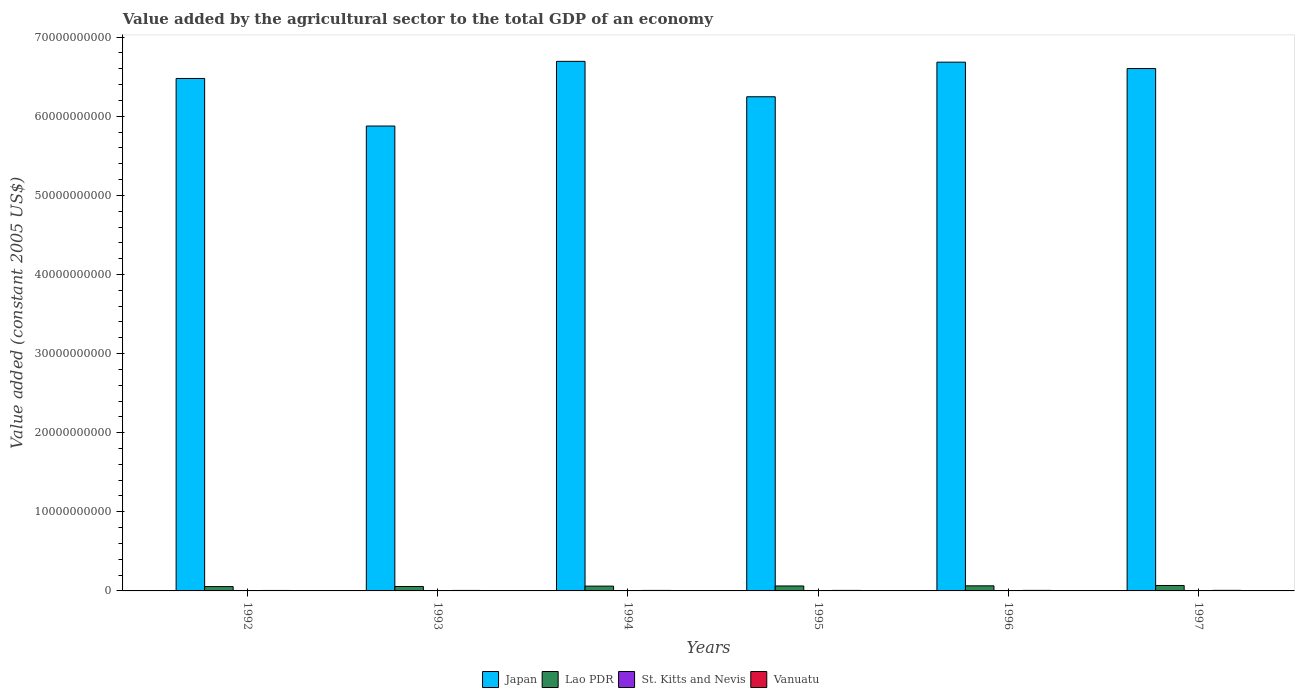Are the number of bars on each tick of the X-axis equal?
Ensure brevity in your answer.  Yes. How many bars are there on the 3rd tick from the right?
Your answer should be very brief. 4. In how many cases, is the number of bars for a given year not equal to the number of legend labels?
Keep it short and to the point. 0. What is the value added by the agricultural sector in Japan in 1995?
Make the answer very short. 6.25e+1. Across all years, what is the maximum value added by the agricultural sector in Vanuatu?
Your response must be concise. 7.22e+07. Across all years, what is the minimum value added by the agricultural sector in Lao PDR?
Keep it short and to the point. 5.46e+08. What is the total value added by the agricultural sector in St. Kitts and Nevis in the graph?
Your answer should be very brief. 4.08e+07. What is the difference between the value added by the agricultural sector in Vanuatu in 1994 and that in 1997?
Offer a very short reply. -8.80e+06. What is the difference between the value added by the agricultural sector in St. Kitts and Nevis in 1997 and the value added by the agricultural sector in Japan in 1995?
Give a very brief answer. -6.25e+1. What is the average value added by the agricultural sector in St. Kitts and Nevis per year?
Your response must be concise. 6.80e+06. In the year 1994, what is the difference between the value added by the agricultural sector in St. Kitts and Nevis and value added by the agricultural sector in Japan?
Ensure brevity in your answer.  -6.69e+1. What is the ratio of the value added by the agricultural sector in Lao PDR in 1993 to that in 1994?
Keep it short and to the point. 0.92. Is the value added by the agricultural sector in Japan in 1994 less than that in 1995?
Your answer should be very brief. No. Is the difference between the value added by the agricultural sector in St. Kitts and Nevis in 1994 and 1996 greater than the difference between the value added by the agricultural sector in Japan in 1994 and 1996?
Make the answer very short. No. What is the difference between the highest and the second highest value added by the agricultural sector in Japan?
Offer a very short reply. 1.02e+08. What is the difference between the highest and the lowest value added by the agricultural sector in Vanuatu?
Your response must be concise. 1.40e+07. In how many years, is the value added by the agricultural sector in Vanuatu greater than the average value added by the agricultural sector in Vanuatu taken over all years?
Keep it short and to the point. 3. Is the sum of the value added by the agricultural sector in Japan in 1995 and 1996 greater than the maximum value added by the agricultural sector in St. Kitts and Nevis across all years?
Provide a succinct answer. Yes. Is it the case that in every year, the sum of the value added by the agricultural sector in Vanuatu and value added by the agricultural sector in Japan is greater than the sum of value added by the agricultural sector in Lao PDR and value added by the agricultural sector in St. Kitts and Nevis?
Provide a succinct answer. No. What does the 1st bar from the right in 1992 represents?
Offer a very short reply. Vanuatu. What is the difference between two consecutive major ticks on the Y-axis?
Provide a short and direct response. 1.00e+1. Does the graph contain grids?
Your answer should be compact. No. Where does the legend appear in the graph?
Your answer should be very brief. Bottom center. What is the title of the graph?
Provide a succinct answer. Value added by the agricultural sector to the total GDP of an economy. What is the label or title of the Y-axis?
Ensure brevity in your answer.  Value added (constant 2005 US$). What is the Value added (constant 2005 US$) in Japan in 1992?
Keep it short and to the point. 6.48e+1. What is the Value added (constant 2005 US$) in Lao PDR in 1992?
Your answer should be compact. 5.46e+08. What is the Value added (constant 2005 US$) in St. Kitts and Nevis in 1992?
Provide a succinct answer. 6.82e+06. What is the Value added (constant 2005 US$) of Vanuatu in 1992?
Your answer should be very brief. 5.82e+07. What is the Value added (constant 2005 US$) of Japan in 1993?
Provide a short and direct response. 5.88e+1. What is the Value added (constant 2005 US$) of Lao PDR in 1993?
Give a very brief answer. 5.60e+08. What is the Value added (constant 2005 US$) in St. Kitts and Nevis in 1993?
Keep it short and to the point. 7.05e+06. What is the Value added (constant 2005 US$) of Vanuatu in 1993?
Your answer should be very brief. 6.26e+07. What is the Value added (constant 2005 US$) in Japan in 1994?
Your answer should be compact. 6.69e+1. What is the Value added (constant 2005 US$) in Lao PDR in 1994?
Keep it short and to the point. 6.07e+08. What is the Value added (constant 2005 US$) of St. Kitts and Nevis in 1994?
Your response must be concise. 7.30e+06. What is the Value added (constant 2005 US$) of Vanuatu in 1994?
Keep it short and to the point. 6.34e+07. What is the Value added (constant 2005 US$) in Japan in 1995?
Your answer should be compact. 6.25e+1. What is the Value added (constant 2005 US$) in Lao PDR in 1995?
Offer a terse response. 6.26e+08. What is the Value added (constant 2005 US$) of St. Kitts and Nevis in 1995?
Provide a succinct answer. 6.03e+06. What is the Value added (constant 2005 US$) of Vanuatu in 1995?
Give a very brief answer. 6.58e+07. What is the Value added (constant 2005 US$) of Japan in 1996?
Make the answer very short. 6.68e+1. What is the Value added (constant 2005 US$) of Lao PDR in 1996?
Ensure brevity in your answer.  6.43e+08. What is the Value added (constant 2005 US$) of St. Kitts and Nevis in 1996?
Offer a terse response. 6.71e+06. What is the Value added (constant 2005 US$) of Vanuatu in 1996?
Your answer should be very brief. 6.90e+07. What is the Value added (constant 2005 US$) in Japan in 1997?
Ensure brevity in your answer.  6.60e+1. What is the Value added (constant 2005 US$) in Lao PDR in 1997?
Your answer should be compact. 6.88e+08. What is the Value added (constant 2005 US$) in St. Kitts and Nevis in 1997?
Provide a short and direct response. 6.89e+06. What is the Value added (constant 2005 US$) in Vanuatu in 1997?
Your answer should be very brief. 7.22e+07. Across all years, what is the maximum Value added (constant 2005 US$) in Japan?
Offer a very short reply. 6.69e+1. Across all years, what is the maximum Value added (constant 2005 US$) in Lao PDR?
Offer a terse response. 6.88e+08. Across all years, what is the maximum Value added (constant 2005 US$) of St. Kitts and Nevis?
Ensure brevity in your answer.  7.30e+06. Across all years, what is the maximum Value added (constant 2005 US$) of Vanuatu?
Give a very brief answer. 7.22e+07. Across all years, what is the minimum Value added (constant 2005 US$) in Japan?
Ensure brevity in your answer.  5.88e+1. Across all years, what is the minimum Value added (constant 2005 US$) in Lao PDR?
Make the answer very short. 5.46e+08. Across all years, what is the minimum Value added (constant 2005 US$) of St. Kitts and Nevis?
Provide a succinct answer. 6.03e+06. Across all years, what is the minimum Value added (constant 2005 US$) of Vanuatu?
Keep it short and to the point. 5.82e+07. What is the total Value added (constant 2005 US$) in Japan in the graph?
Provide a short and direct response. 3.86e+11. What is the total Value added (constant 2005 US$) of Lao PDR in the graph?
Provide a short and direct response. 3.67e+09. What is the total Value added (constant 2005 US$) in St. Kitts and Nevis in the graph?
Give a very brief answer. 4.08e+07. What is the total Value added (constant 2005 US$) in Vanuatu in the graph?
Your answer should be very brief. 3.91e+08. What is the difference between the Value added (constant 2005 US$) in Japan in 1992 and that in 1993?
Provide a succinct answer. 6.01e+09. What is the difference between the Value added (constant 2005 US$) in Lao PDR in 1992 and that in 1993?
Your answer should be compact. -1.48e+07. What is the difference between the Value added (constant 2005 US$) of St. Kitts and Nevis in 1992 and that in 1993?
Offer a very short reply. -2.24e+05. What is the difference between the Value added (constant 2005 US$) in Vanuatu in 1992 and that in 1993?
Keep it short and to the point. -4.45e+06. What is the difference between the Value added (constant 2005 US$) in Japan in 1992 and that in 1994?
Offer a terse response. -2.16e+09. What is the difference between the Value added (constant 2005 US$) of Lao PDR in 1992 and that in 1994?
Your answer should be compact. -6.13e+07. What is the difference between the Value added (constant 2005 US$) in St. Kitts and Nevis in 1992 and that in 1994?
Your answer should be very brief. -4.82e+05. What is the difference between the Value added (constant 2005 US$) in Vanuatu in 1992 and that in 1994?
Give a very brief answer. -5.24e+06. What is the difference between the Value added (constant 2005 US$) of Japan in 1992 and that in 1995?
Provide a succinct answer. 2.31e+09. What is the difference between the Value added (constant 2005 US$) in Lao PDR in 1992 and that in 1995?
Your answer should be very brief. -8.03e+07. What is the difference between the Value added (constant 2005 US$) of St. Kitts and Nevis in 1992 and that in 1995?
Make the answer very short. 7.95e+05. What is the difference between the Value added (constant 2005 US$) of Vanuatu in 1992 and that in 1995?
Your response must be concise. -7.66e+06. What is the difference between the Value added (constant 2005 US$) of Japan in 1992 and that in 1996?
Your response must be concise. -2.06e+09. What is the difference between the Value added (constant 2005 US$) in Lao PDR in 1992 and that in 1996?
Your answer should be very brief. -9.69e+07. What is the difference between the Value added (constant 2005 US$) in St. Kitts and Nevis in 1992 and that in 1996?
Offer a terse response. 1.18e+05. What is the difference between the Value added (constant 2005 US$) of Vanuatu in 1992 and that in 1996?
Give a very brief answer. -1.08e+07. What is the difference between the Value added (constant 2005 US$) in Japan in 1992 and that in 1997?
Offer a terse response. -1.25e+09. What is the difference between the Value added (constant 2005 US$) of Lao PDR in 1992 and that in 1997?
Provide a succinct answer. -1.42e+08. What is the difference between the Value added (constant 2005 US$) in St. Kitts and Nevis in 1992 and that in 1997?
Provide a short and direct response. -6.55e+04. What is the difference between the Value added (constant 2005 US$) of Vanuatu in 1992 and that in 1997?
Your answer should be compact. -1.40e+07. What is the difference between the Value added (constant 2005 US$) of Japan in 1993 and that in 1994?
Provide a succinct answer. -8.18e+09. What is the difference between the Value added (constant 2005 US$) of Lao PDR in 1993 and that in 1994?
Provide a succinct answer. -4.65e+07. What is the difference between the Value added (constant 2005 US$) of St. Kitts and Nevis in 1993 and that in 1994?
Keep it short and to the point. -2.58e+05. What is the difference between the Value added (constant 2005 US$) of Vanuatu in 1993 and that in 1994?
Offer a very short reply. -7.90e+05. What is the difference between the Value added (constant 2005 US$) of Japan in 1993 and that in 1995?
Offer a terse response. -3.70e+09. What is the difference between the Value added (constant 2005 US$) of Lao PDR in 1993 and that in 1995?
Give a very brief answer. -6.56e+07. What is the difference between the Value added (constant 2005 US$) in St. Kitts and Nevis in 1993 and that in 1995?
Make the answer very short. 1.02e+06. What is the difference between the Value added (constant 2005 US$) in Vanuatu in 1993 and that in 1995?
Give a very brief answer. -3.21e+06. What is the difference between the Value added (constant 2005 US$) in Japan in 1993 and that in 1996?
Your answer should be very brief. -8.07e+09. What is the difference between the Value added (constant 2005 US$) of Lao PDR in 1993 and that in 1996?
Give a very brief answer. -8.21e+07. What is the difference between the Value added (constant 2005 US$) of St. Kitts and Nevis in 1993 and that in 1996?
Your answer should be very brief. 3.42e+05. What is the difference between the Value added (constant 2005 US$) in Vanuatu in 1993 and that in 1996?
Provide a succinct answer. -6.39e+06. What is the difference between the Value added (constant 2005 US$) in Japan in 1993 and that in 1997?
Provide a short and direct response. -7.26e+09. What is the difference between the Value added (constant 2005 US$) of Lao PDR in 1993 and that in 1997?
Your answer should be very brief. -1.28e+08. What is the difference between the Value added (constant 2005 US$) in St. Kitts and Nevis in 1993 and that in 1997?
Your response must be concise. 1.59e+05. What is the difference between the Value added (constant 2005 US$) of Vanuatu in 1993 and that in 1997?
Your answer should be very brief. -9.59e+06. What is the difference between the Value added (constant 2005 US$) of Japan in 1994 and that in 1995?
Make the answer very short. 4.48e+09. What is the difference between the Value added (constant 2005 US$) in Lao PDR in 1994 and that in 1995?
Your answer should be very brief. -1.91e+07. What is the difference between the Value added (constant 2005 US$) of St. Kitts and Nevis in 1994 and that in 1995?
Keep it short and to the point. 1.28e+06. What is the difference between the Value added (constant 2005 US$) in Vanuatu in 1994 and that in 1995?
Provide a short and direct response. -2.42e+06. What is the difference between the Value added (constant 2005 US$) in Japan in 1994 and that in 1996?
Your response must be concise. 1.02e+08. What is the difference between the Value added (constant 2005 US$) in Lao PDR in 1994 and that in 1996?
Your response must be concise. -3.56e+07. What is the difference between the Value added (constant 2005 US$) of St. Kitts and Nevis in 1994 and that in 1996?
Your answer should be very brief. 6.00e+05. What is the difference between the Value added (constant 2005 US$) in Vanuatu in 1994 and that in 1996?
Give a very brief answer. -5.60e+06. What is the difference between the Value added (constant 2005 US$) of Japan in 1994 and that in 1997?
Your response must be concise. 9.11e+08. What is the difference between the Value added (constant 2005 US$) of Lao PDR in 1994 and that in 1997?
Offer a very short reply. -8.11e+07. What is the difference between the Value added (constant 2005 US$) in St. Kitts and Nevis in 1994 and that in 1997?
Give a very brief answer. 4.17e+05. What is the difference between the Value added (constant 2005 US$) in Vanuatu in 1994 and that in 1997?
Ensure brevity in your answer.  -8.80e+06. What is the difference between the Value added (constant 2005 US$) of Japan in 1995 and that in 1996?
Give a very brief answer. -4.37e+09. What is the difference between the Value added (constant 2005 US$) of Lao PDR in 1995 and that in 1996?
Your answer should be compact. -1.65e+07. What is the difference between the Value added (constant 2005 US$) of St. Kitts and Nevis in 1995 and that in 1996?
Your response must be concise. -6.77e+05. What is the difference between the Value added (constant 2005 US$) of Vanuatu in 1995 and that in 1996?
Your answer should be very brief. -3.18e+06. What is the difference between the Value added (constant 2005 US$) of Japan in 1995 and that in 1997?
Your response must be concise. -3.56e+09. What is the difference between the Value added (constant 2005 US$) in Lao PDR in 1995 and that in 1997?
Ensure brevity in your answer.  -6.20e+07. What is the difference between the Value added (constant 2005 US$) of St. Kitts and Nevis in 1995 and that in 1997?
Offer a terse response. -8.60e+05. What is the difference between the Value added (constant 2005 US$) in Vanuatu in 1995 and that in 1997?
Ensure brevity in your answer.  -6.39e+06. What is the difference between the Value added (constant 2005 US$) of Japan in 1996 and that in 1997?
Provide a short and direct response. 8.09e+08. What is the difference between the Value added (constant 2005 US$) in Lao PDR in 1996 and that in 1997?
Your answer should be compact. -4.55e+07. What is the difference between the Value added (constant 2005 US$) in St. Kitts and Nevis in 1996 and that in 1997?
Your response must be concise. -1.83e+05. What is the difference between the Value added (constant 2005 US$) of Vanuatu in 1996 and that in 1997?
Keep it short and to the point. -3.21e+06. What is the difference between the Value added (constant 2005 US$) of Japan in 1992 and the Value added (constant 2005 US$) of Lao PDR in 1993?
Provide a short and direct response. 6.42e+1. What is the difference between the Value added (constant 2005 US$) in Japan in 1992 and the Value added (constant 2005 US$) in St. Kitts and Nevis in 1993?
Provide a short and direct response. 6.48e+1. What is the difference between the Value added (constant 2005 US$) in Japan in 1992 and the Value added (constant 2005 US$) in Vanuatu in 1993?
Offer a terse response. 6.47e+1. What is the difference between the Value added (constant 2005 US$) in Lao PDR in 1992 and the Value added (constant 2005 US$) in St. Kitts and Nevis in 1993?
Ensure brevity in your answer.  5.39e+08. What is the difference between the Value added (constant 2005 US$) in Lao PDR in 1992 and the Value added (constant 2005 US$) in Vanuatu in 1993?
Offer a terse response. 4.83e+08. What is the difference between the Value added (constant 2005 US$) of St. Kitts and Nevis in 1992 and the Value added (constant 2005 US$) of Vanuatu in 1993?
Your answer should be very brief. -5.58e+07. What is the difference between the Value added (constant 2005 US$) of Japan in 1992 and the Value added (constant 2005 US$) of Lao PDR in 1994?
Offer a terse response. 6.42e+1. What is the difference between the Value added (constant 2005 US$) of Japan in 1992 and the Value added (constant 2005 US$) of St. Kitts and Nevis in 1994?
Offer a terse response. 6.48e+1. What is the difference between the Value added (constant 2005 US$) in Japan in 1992 and the Value added (constant 2005 US$) in Vanuatu in 1994?
Give a very brief answer. 6.47e+1. What is the difference between the Value added (constant 2005 US$) of Lao PDR in 1992 and the Value added (constant 2005 US$) of St. Kitts and Nevis in 1994?
Your answer should be compact. 5.38e+08. What is the difference between the Value added (constant 2005 US$) of Lao PDR in 1992 and the Value added (constant 2005 US$) of Vanuatu in 1994?
Your answer should be very brief. 4.82e+08. What is the difference between the Value added (constant 2005 US$) in St. Kitts and Nevis in 1992 and the Value added (constant 2005 US$) in Vanuatu in 1994?
Your answer should be very brief. -5.66e+07. What is the difference between the Value added (constant 2005 US$) of Japan in 1992 and the Value added (constant 2005 US$) of Lao PDR in 1995?
Ensure brevity in your answer.  6.42e+1. What is the difference between the Value added (constant 2005 US$) of Japan in 1992 and the Value added (constant 2005 US$) of St. Kitts and Nevis in 1995?
Your answer should be compact. 6.48e+1. What is the difference between the Value added (constant 2005 US$) in Japan in 1992 and the Value added (constant 2005 US$) in Vanuatu in 1995?
Provide a short and direct response. 6.47e+1. What is the difference between the Value added (constant 2005 US$) of Lao PDR in 1992 and the Value added (constant 2005 US$) of St. Kitts and Nevis in 1995?
Offer a very short reply. 5.40e+08. What is the difference between the Value added (constant 2005 US$) in Lao PDR in 1992 and the Value added (constant 2005 US$) in Vanuatu in 1995?
Your answer should be very brief. 4.80e+08. What is the difference between the Value added (constant 2005 US$) of St. Kitts and Nevis in 1992 and the Value added (constant 2005 US$) of Vanuatu in 1995?
Provide a succinct answer. -5.90e+07. What is the difference between the Value added (constant 2005 US$) of Japan in 1992 and the Value added (constant 2005 US$) of Lao PDR in 1996?
Provide a short and direct response. 6.41e+1. What is the difference between the Value added (constant 2005 US$) of Japan in 1992 and the Value added (constant 2005 US$) of St. Kitts and Nevis in 1996?
Provide a succinct answer. 6.48e+1. What is the difference between the Value added (constant 2005 US$) of Japan in 1992 and the Value added (constant 2005 US$) of Vanuatu in 1996?
Give a very brief answer. 6.47e+1. What is the difference between the Value added (constant 2005 US$) in Lao PDR in 1992 and the Value added (constant 2005 US$) in St. Kitts and Nevis in 1996?
Offer a very short reply. 5.39e+08. What is the difference between the Value added (constant 2005 US$) in Lao PDR in 1992 and the Value added (constant 2005 US$) in Vanuatu in 1996?
Keep it short and to the point. 4.77e+08. What is the difference between the Value added (constant 2005 US$) of St. Kitts and Nevis in 1992 and the Value added (constant 2005 US$) of Vanuatu in 1996?
Ensure brevity in your answer.  -6.22e+07. What is the difference between the Value added (constant 2005 US$) in Japan in 1992 and the Value added (constant 2005 US$) in Lao PDR in 1997?
Provide a succinct answer. 6.41e+1. What is the difference between the Value added (constant 2005 US$) of Japan in 1992 and the Value added (constant 2005 US$) of St. Kitts and Nevis in 1997?
Keep it short and to the point. 6.48e+1. What is the difference between the Value added (constant 2005 US$) in Japan in 1992 and the Value added (constant 2005 US$) in Vanuatu in 1997?
Make the answer very short. 6.47e+1. What is the difference between the Value added (constant 2005 US$) of Lao PDR in 1992 and the Value added (constant 2005 US$) of St. Kitts and Nevis in 1997?
Your answer should be very brief. 5.39e+08. What is the difference between the Value added (constant 2005 US$) of Lao PDR in 1992 and the Value added (constant 2005 US$) of Vanuatu in 1997?
Keep it short and to the point. 4.73e+08. What is the difference between the Value added (constant 2005 US$) in St. Kitts and Nevis in 1992 and the Value added (constant 2005 US$) in Vanuatu in 1997?
Your answer should be very brief. -6.54e+07. What is the difference between the Value added (constant 2005 US$) in Japan in 1993 and the Value added (constant 2005 US$) in Lao PDR in 1994?
Provide a succinct answer. 5.82e+1. What is the difference between the Value added (constant 2005 US$) in Japan in 1993 and the Value added (constant 2005 US$) in St. Kitts and Nevis in 1994?
Keep it short and to the point. 5.88e+1. What is the difference between the Value added (constant 2005 US$) in Japan in 1993 and the Value added (constant 2005 US$) in Vanuatu in 1994?
Provide a short and direct response. 5.87e+1. What is the difference between the Value added (constant 2005 US$) in Lao PDR in 1993 and the Value added (constant 2005 US$) in St. Kitts and Nevis in 1994?
Your answer should be very brief. 5.53e+08. What is the difference between the Value added (constant 2005 US$) in Lao PDR in 1993 and the Value added (constant 2005 US$) in Vanuatu in 1994?
Offer a very short reply. 4.97e+08. What is the difference between the Value added (constant 2005 US$) in St. Kitts and Nevis in 1993 and the Value added (constant 2005 US$) in Vanuatu in 1994?
Your answer should be very brief. -5.64e+07. What is the difference between the Value added (constant 2005 US$) of Japan in 1993 and the Value added (constant 2005 US$) of Lao PDR in 1995?
Your response must be concise. 5.81e+1. What is the difference between the Value added (constant 2005 US$) in Japan in 1993 and the Value added (constant 2005 US$) in St. Kitts and Nevis in 1995?
Your response must be concise. 5.88e+1. What is the difference between the Value added (constant 2005 US$) of Japan in 1993 and the Value added (constant 2005 US$) of Vanuatu in 1995?
Provide a short and direct response. 5.87e+1. What is the difference between the Value added (constant 2005 US$) of Lao PDR in 1993 and the Value added (constant 2005 US$) of St. Kitts and Nevis in 1995?
Provide a succinct answer. 5.54e+08. What is the difference between the Value added (constant 2005 US$) in Lao PDR in 1993 and the Value added (constant 2005 US$) in Vanuatu in 1995?
Ensure brevity in your answer.  4.95e+08. What is the difference between the Value added (constant 2005 US$) of St. Kitts and Nevis in 1993 and the Value added (constant 2005 US$) of Vanuatu in 1995?
Offer a terse response. -5.88e+07. What is the difference between the Value added (constant 2005 US$) of Japan in 1993 and the Value added (constant 2005 US$) of Lao PDR in 1996?
Ensure brevity in your answer.  5.81e+1. What is the difference between the Value added (constant 2005 US$) of Japan in 1993 and the Value added (constant 2005 US$) of St. Kitts and Nevis in 1996?
Give a very brief answer. 5.88e+1. What is the difference between the Value added (constant 2005 US$) in Japan in 1993 and the Value added (constant 2005 US$) in Vanuatu in 1996?
Offer a very short reply. 5.87e+1. What is the difference between the Value added (constant 2005 US$) in Lao PDR in 1993 and the Value added (constant 2005 US$) in St. Kitts and Nevis in 1996?
Give a very brief answer. 5.54e+08. What is the difference between the Value added (constant 2005 US$) in Lao PDR in 1993 and the Value added (constant 2005 US$) in Vanuatu in 1996?
Your answer should be very brief. 4.91e+08. What is the difference between the Value added (constant 2005 US$) in St. Kitts and Nevis in 1993 and the Value added (constant 2005 US$) in Vanuatu in 1996?
Your answer should be very brief. -6.20e+07. What is the difference between the Value added (constant 2005 US$) in Japan in 1993 and the Value added (constant 2005 US$) in Lao PDR in 1997?
Offer a terse response. 5.81e+1. What is the difference between the Value added (constant 2005 US$) in Japan in 1993 and the Value added (constant 2005 US$) in St. Kitts and Nevis in 1997?
Keep it short and to the point. 5.88e+1. What is the difference between the Value added (constant 2005 US$) of Japan in 1993 and the Value added (constant 2005 US$) of Vanuatu in 1997?
Provide a succinct answer. 5.87e+1. What is the difference between the Value added (constant 2005 US$) of Lao PDR in 1993 and the Value added (constant 2005 US$) of St. Kitts and Nevis in 1997?
Give a very brief answer. 5.54e+08. What is the difference between the Value added (constant 2005 US$) in Lao PDR in 1993 and the Value added (constant 2005 US$) in Vanuatu in 1997?
Offer a very short reply. 4.88e+08. What is the difference between the Value added (constant 2005 US$) of St. Kitts and Nevis in 1993 and the Value added (constant 2005 US$) of Vanuatu in 1997?
Offer a very short reply. -6.52e+07. What is the difference between the Value added (constant 2005 US$) of Japan in 1994 and the Value added (constant 2005 US$) of Lao PDR in 1995?
Offer a very short reply. 6.63e+1. What is the difference between the Value added (constant 2005 US$) of Japan in 1994 and the Value added (constant 2005 US$) of St. Kitts and Nevis in 1995?
Keep it short and to the point. 6.69e+1. What is the difference between the Value added (constant 2005 US$) of Japan in 1994 and the Value added (constant 2005 US$) of Vanuatu in 1995?
Your answer should be very brief. 6.69e+1. What is the difference between the Value added (constant 2005 US$) in Lao PDR in 1994 and the Value added (constant 2005 US$) in St. Kitts and Nevis in 1995?
Give a very brief answer. 6.01e+08. What is the difference between the Value added (constant 2005 US$) of Lao PDR in 1994 and the Value added (constant 2005 US$) of Vanuatu in 1995?
Provide a short and direct response. 5.41e+08. What is the difference between the Value added (constant 2005 US$) in St. Kitts and Nevis in 1994 and the Value added (constant 2005 US$) in Vanuatu in 1995?
Provide a succinct answer. -5.85e+07. What is the difference between the Value added (constant 2005 US$) in Japan in 1994 and the Value added (constant 2005 US$) in Lao PDR in 1996?
Provide a short and direct response. 6.63e+1. What is the difference between the Value added (constant 2005 US$) of Japan in 1994 and the Value added (constant 2005 US$) of St. Kitts and Nevis in 1996?
Ensure brevity in your answer.  6.69e+1. What is the difference between the Value added (constant 2005 US$) in Japan in 1994 and the Value added (constant 2005 US$) in Vanuatu in 1996?
Make the answer very short. 6.69e+1. What is the difference between the Value added (constant 2005 US$) in Lao PDR in 1994 and the Value added (constant 2005 US$) in St. Kitts and Nevis in 1996?
Give a very brief answer. 6.00e+08. What is the difference between the Value added (constant 2005 US$) of Lao PDR in 1994 and the Value added (constant 2005 US$) of Vanuatu in 1996?
Provide a short and direct response. 5.38e+08. What is the difference between the Value added (constant 2005 US$) of St. Kitts and Nevis in 1994 and the Value added (constant 2005 US$) of Vanuatu in 1996?
Give a very brief answer. -6.17e+07. What is the difference between the Value added (constant 2005 US$) in Japan in 1994 and the Value added (constant 2005 US$) in Lao PDR in 1997?
Provide a short and direct response. 6.63e+1. What is the difference between the Value added (constant 2005 US$) in Japan in 1994 and the Value added (constant 2005 US$) in St. Kitts and Nevis in 1997?
Offer a very short reply. 6.69e+1. What is the difference between the Value added (constant 2005 US$) of Japan in 1994 and the Value added (constant 2005 US$) of Vanuatu in 1997?
Provide a succinct answer. 6.69e+1. What is the difference between the Value added (constant 2005 US$) in Lao PDR in 1994 and the Value added (constant 2005 US$) in St. Kitts and Nevis in 1997?
Give a very brief answer. 6.00e+08. What is the difference between the Value added (constant 2005 US$) of Lao PDR in 1994 and the Value added (constant 2005 US$) of Vanuatu in 1997?
Provide a succinct answer. 5.35e+08. What is the difference between the Value added (constant 2005 US$) in St. Kitts and Nevis in 1994 and the Value added (constant 2005 US$) in Vanuatu in 1997?
Keep it short and to the point. -6.49e+07. What is the difference between the Value added (constant 2005 US$) in Japan in 1995 and the Value added (constant 2005 US$) in Lao PDR in 1996?
Your answer should be compact. 6.18e+1. What is the difference between the Value added (constant 2005 US$) in Japan in 1995 and the Value added (constant 2005 US$) in St. Kitts and Nevis in 1996?
Make the answer very short. 6.25e+1. What is the difference between the Value added (constant 2005 US$) of Japan in 1995 and the Value added (constant 2005 US$) of Vanuatu in 1996?
Make the answer very short. 6.24e+1. What is the difference between the Value added (constant 2005 US$) in Lao PDR in 1995 and the Value added (constant 2005 US$) in St. Kitts and Nevis in 1996?
Provide a short and direct response. 6.19e+08. What is the difference between the Value added (constant 2005 US$) in Lao PDR in 1995 and the Value added (constant 2005 US$) in Vanuatu in 1996?
Give a very brief answer. 5.57e+08. What is the difference between the Value added (constant 2005 US$) in St. Kitts and Nevis in 1995 and the Value added (constant 2005 US$) in Vanuatu in 1996?
Make the answer very short. -6.30e+07. What is the difference between the Value added (constant 2005 US$) in Japan in 1995 and the Value added (constant 2005 US$) in Lao PDR in 1997?
Ensure brevity in your answer.  6.18e+1. What is the difference between the Value added (constant 2005 US$) of Japan in 1995 and the Value added (constant 2005 US$) of St. Kitts and Nevis in 1997?
Ensure brevity in your answer.  6.25e+1. What is the difference between the Value added (constant 2005 US$) in Japan in 1995 and the Value added (constant 2005 US$) in Vanuatu in 1997?
Keep it short and to the point. 6.24e+1. What is the difference between the Value added (constant 2005 US$) of Lao PDR in 1995 and the Value added (constant 2005 US$) of St. Kitts and Nevis in 1997?
Give a very brief answer. 6.19e+08. What is the difference between the Value added (constant 2005 US$) of Lao PDR in 1995 and the Value added (constant 2005 US$) of Vanuatu in 1997?
Keep it short and to the point. 5.54e+08. What is the difference between the Value added (constant 2005 US$) in St. Kitts and Nevis in 1995 and the Value added (constant 2005 US$) in Vanuatu in 1997?
Your answer should be very brief. -6.62e+07. What is the difference between the Value added (constant 2005 US$) in Japan in 1996 and the Value added (constant 2005 US$) in Lao PDR in 1997?
Give a very brief answer. 6.62e+1. What is the difference between the Value added (constant 2005 US$) of Japan in 1996 and the Value added (constant 2005 US$) of St. Kitts and Nevis in 1997?
Ensure brevity in your answer.  6.68e+1. What is the difference between the Value added (constant 2005 US$) of Japan in 1996 and the Value added (constant 2005 US$) of Vanuatu in 1997?
Provide a succinct answer. 6.68e+1. What is the difference between the Value added (constant 2005 US$) of Lao PDR in 1996 and the Value added (constant 2005 US$) of St. Kitts and Nevis in 1997?
Ensure brevity in your answer.  6.36e+08. What is the difference between the Value added (constant 2005 US$) of Lao PDR in 1996 and the Value added (constant 2005 US$) of Vanuatu in 1997?
Provide a short and direct response. 5.70e+08. What is the difference between the Value added (constant 2005 US$) of St. Kitts and Nevis in 1996 and the Value added (constant 2005 US$) of Vanuatu in 1997?
Your answer should be very brief. -6.55e+07. What is the average Value added (constant 2005 US$) in Japan per year?
Make the answer very short. 6.43e+1. What is the average Value added (constant 2005 US$) in Lao PDR per year?
Offer a very short reply. 6.12e+08. What is the average Value added (constant 2005 US$) in St. Kitts and Nevis per year?
Offer a terse response. 6.80e+06. What is the average Value added (constant 2005 US$) of Vanuatu per year?
Your response must be concise. 6.52e+07. In the year 1992, what is the difference between the Value added (constant 2005 US$) of Japan and Value added (constant 2005 US$) of Lao PDR?
Offer a terse response. 6.42e+1. In the year 1992, what is the difference between the Value added (constant 2005 US$) of Japan and Value added (constant 2005 US$) of St. Kitts and Nevis?
Keep it short and to the point. 6.48e+1. In the year 1992, what is the difference between the Value added (constant 2005 US$) in Japan and Value added (constant 2005 US$) in Vanuatu?
Provide a short and direct response. 6.47e+1. In the year 1992, what is the difference between the Value added (constant 2005 US$) in Lao PDR and Value added (constant 2005 US$) in St. Kitts and Nevis?
Your answer should be compact. 5.39e+08. In the year 1992, what is the difference between the Value added (constant 2005 US$) of Lao PDR and Value added (constant 2005 US$) of Vanuatu?
Provide a succinct answer. 4.87e+08. In the year 1992, what is the difference between the Value added (constant 2005 US$) of St. Kitts and Nevis and Value added (constant 2005 US$) of Vanuatu?
Offer a terse response. -5.13e+07. In the year 1993, what is the difference between the Value added (constant 2005 US$) of Japan and Value added (constant 2005 US$) of Lao PDR?
Give a very brief answer. 5.82e+1. In the year 1993, what is the difference between the Value added (constant 2005 US$) of Japan and Value added (constant 2005 US$) of St. Kitts and Nevis?
Offer a very short reply. 5.88e+1. In the year 1993, what is the difference between the Value added (constant 2005 US$) of Japan and Value added (constant 2005 US$) of Vanuatu?
Offer a terse response. 5.87e+1. In the year 1993, what is the difference between the Value added (constant 2005 US$) of Lao PDR and Value added (constant 2005 US$) of St. Kitts and Nevis?
Offer a terse response. 5.53e+08. In the year 1993, what is the difference between the Value added (constant 2005 US$) of Lao PDR and Value added (constant 2005 US$) of Vanuatu?
Offer a terse response. 4.98e+08. In the year 1993, what is the difference between the Value added (constant 2005 US$) of St. Kitts and Nevis and Value added (constant 2005 US$) of Vanuatu?
Your answer should be very brief. -5.56e+07. In the year 1994, what is the difference between the Value added (constant 2005 US$) of Japan and Value added (constant 2005 US$) of Lao PDR?
Your answer should be compact. 6.63e+1. In the year 1994, what is the difference between the Value added (constant 2005 US$) of Japan and Value added (constant 2005 US$) of St. Kitts and Nevis?
Offer a very short reply. 6.69e+1. In the year 1994, what is the difference between the Value added (constant 2005 US$) in Japan and Value added (constant 2005 US$) in Vanuatu?
Offer a very short reply. 6.69e+1. In the year 1994, what is the difference between the Value added (constant 2005 US$) in Lao PDR and Value added (constant 2005 US$) in St. Kitts and Nevis?
Provide a short and direct response. 6.00e+08. In the year 1994, what is the difference between the Value added (constant 2005 US$) in Lao PDR and Value added (constant 2005 US$) in Vanuatu?
Give a very brief answer. 5.44e+08. In the year 1994, what is the difference between the Value added (constant 2005 US$) in St. Kitts and Nevis and Value added (constant 2005 US$) in Vanuatu?
Your answer should be very brief. -5.61e+07. In the year 1995, what is the difference between the Value added (constant 2005 US$) of Japan and Value added (constant 2005 US$) of Lao PDR?
Your answer should be compact. 6.18e+1. In the year 1995, what is the difference between the Value added (constant 2005 US$) of Japan and Value added (constant 2005 US$) of St. Kitts and Nevis?
Provide a short and direct response. 6.25e+1. In the year 1995, what is the difference between the Value added (constant 2005 US$) of Japan and Value added (constant 2005 US$) of Vanuatu?
Keep it short and to the point. 6.24e+1. In the year 1995, what is the difference between the Value added (constant 2005 US$) in Lao PDR and Value added (constant 2005 US$) in St. Kitts and Nevis?
Give a very brief answer. 6.20e+08. In the year 1995, what is the difference between the Value added (constant 2005 US$) of Lao PDR and Value added (constant 2005 US$) of Vanuatu?
Provide a succinct answer. 5.60e+08. In the year 1995, what is the difference between the Value added (constant 2005 US$) of St. Kitts and Nevis and Value added (constant 2005 US$) of Vanuatu?
Ensure brevity in your answer.  -5.98e+07. In the year 1996, what is the difference between the Value added (constant 2005 US$) in Japan and Value added (constant 2005 US$) in Lao PDR?
Offer a very short reply. 6.62e+1. In the year 1996, what is the difference between the Value added (constant 2005 US$) of Japan and Value added (constant 2005 US$) of St. Kitts and Nevis?
Provide a succinct answer. 6.68e+1. In the year 1996, what is the difference between the Value added (constant 2005 US$) of Japan and Value added (constant 2005 US$) of Vanuatu?
Offer a very short reply. 6.68e+1. In the year 1996, what is the difference between the Value added (constant 2005 US$) of Lao PDR and Value added (constant 2005 US$) of St. Kitts and Nevis?
Provide a succinct answer. 6.36e+08. In the year 1996, what is the difference between the Value added (constant 2005 US$) of Lao PDR and Value added (constant 2005 US$) of Vanuatu?
Provide a succinct answer. 5.74e+08. In the year 1996, what is the difference between the Value added (constant 2005 US$) in St. Kitts and Nevis and Value added (constant 2005 US$) in Vanuatu?
Keep it short and to the point. -6.23e+07. In the year 1997, what is the difference between the Value added (constant 2005 US$) in Japan and Value added (constant 2005 US$) in Lao PDR?
Your response must be concise. 6.53e+1. In the year 1997, what is the difference between the Value added (constant 2005 US$) of Japan and Value added (constant 2005 US$) of St. Kitts and Nevis?
Offer a very short reply. 6.60e+1. In the year 1997, what is the difference between the Value added (constant 2005 US$) of Japan and Value added (constant 2005 US$) of Vanuatu?
Offer a terse response. 6.60e+1. In the year 1997, what is the difference between the Value added (constant 2005 US$) in Lao PDR and Value added (constant 2005 US$) in St. Kitts and Nevis?
Provide a short and direct response. 6.81e+08. In the year 1997, what is the difference between the Value added (constant 2005 US$) in Lao PDR and Value added (constant 2005 US$) in Vanuatu?
Ensure brevity in your answer.  6.16e+08. In the year 1997, what is the difference between the Value added (constant 2005 US$) in St. Kitts and Nevis and Value added (constant 2005 US$) in Vanuatu?
Your answer should be very brief. -6.53e+07. What is the ratio of the Value added (constant 2005 US$) in Japan in 1992 to that in 1993?
Keep it short and to the point. 1.1. What is the ratio of the Value added (constant 2005 US$) of Lao PDR in 1992 to that in 1993?
Your response must be concise. 0.97. What is the ratio of the Value added (constant 2005 US$) in St. Kitts and Nevis in 1992 to that in 1993?
Keep it short and to the point. 0.97. What is the ratio of the Value added (constant 2005 US$) of Vanuatu in 1992 to that in 1993?
Offer a very short reply. 0.93. What is the ratio of the Value added (constant 2005 US$) in Lao PDR in 1992 to that in 1994?
Provide a short and direct response. 0.9. What is the ratio of the Value added (constant 2005 US$) in St. Kitts and Nevis in 1992 to that in 1994?
Keep it short and to the point. 0.93. What is the ratio of the Value added (constant 2005 US$) in Vanuatu in 1992 to that in 1994?
Give a very brief answer. 0.92. What is the ratio of the Value added (constant 2005 US$) in Japan in 1992 to that in 1995?
Give a very brief answer. 1.04. What is the ratio of the Value added (constant 2005 US$) in Lao PDR in 1992 to that in 1995?
Your answer should be very brief. 0.87. What is the ratio of the Value added (constant 2005 US$) in St. Kitts and Nevis in 1992 to that in 1995?
Keep it short and to the point. 1.13. What is the ratio of the Value added (constant 2005 US$) in Vanuatu in 1992 to that in 1995?
Your answer should be compact. 0.88. What is the ratio of the Value added (constant 2005 US$) of Japan in 1992 to that in 1996?
Offer a very short reply. 0.97. What is the ratio of the Value added (constant 2005 US$) of Lao PDR in 1992 to that in 1996?
Make the answer very short. 0.85. What is the ratio of the Value added (constant 2005 US$) in St. Kitts and Nevis in 1992 to that in 1996?
Your answer should be compact. 1.02. What is the ratio of the Value added (constant 2005 US$) in Vanuatu in 1992 to that in 1996?
Make the answer very short. 0.84. What is the ratio of the Value added (constant 2005 US$) of Japan in 1992 to that in 1997?
Provide a short and direct response. 0.98. What is the ratio of the Value added (constant 2005 US$) in Lao PDR in 1992 to that in 1997?
Keep it short and to the point. 0.79. What is the ratio of the Value added (constant 2005 US$) of St. Kitts and Nevis in 1992 to that in 1997?
Your response must be concise. 0.99. What is the ratio of the Value added (constant 2005 US$) of Vanuatu in 1992 to that in 1997?
Keep it short and to the point. 0.81. What is the ratio of the Value added (constant 2005 US$) in Japan in 1993 to that in 1994?
Offer a terse response. 0.88. What is the ratio of the Value added (constant 2005 US$) in Lao PDR in 1993 to that in 1994?
Provide a succinct answer. 0.92. What is the ratio of the Value added (constant 2005 US$) of St. Kitts and Nevis in 1993 to that in 1994?
Your answer should be very brief. 0.96. What is the ratio of the Value added (constant 2005 US$) of Vanuatu in 1993 to that in 1994?
Keep it short and to the point. 0.99. What is the ratio of the Value added (constant 2005 US$) in Japan in 1993 to that in 1995?
Your answer should be very brief. 0.94. What is the ratio of the Value added (constant 2005 US$) in Lao PDR in 1993 to that in 1995?
Your answer should be compact. 0.9. What is the ratio of the Value added (constant 2005 US$) of St. Kitts and Nevis in 1993 to that in 1995?
Keep it short and to the point. 1.17. What is the ratio of the Value added (constant 2005 US$) of Vanuatu in 1993 to that in 1995?
Make the answer very short. 0.95. What is the ratio of the Value added (constant 2005 US$) in Japan in 1993 to that in 1996?
Your response must be concise. 0.88. What is the ratio of the Value added (constant 2005 US$) in Lao PDR in 1993 to that in 1996?
Your answer should be very brief. 0.87. What is the ratio of the Value added (constant 2005 US$) of St. Kitts and Nevis in 1993 to that in 1996?
Offer a terse response. 1.05. What is the ratio of the Value added (constant 2005 US$) of Vanuatu in 1993 to that in 1996?
Provide a short and direct response. 0.91. What is the ratio of the Value added (constant 2005 US$) in Japan in 1993 to that in 1997?
Provide a succinct answer. 0.89. What is the ratio of the Value added (constant 2005 US$) of Lao PDR in 1993 to that in 1997?
Provide a short and direct response. 0.81. What is the ratio of the Value added (constant 2005 US$) of St. Kitts and Nevis in 1993 to that in 1997?
Provide a succinct answer. 1.02. What is the ratio of the Value added (constant 2005 US$) in Vanuatu in 1993 to that in 1997?
Make the answer very short. 0.87. What is the ratio of the Value added (constant 2005 US$) in Japan in 1994 to that in 1995?
Your answer should be compact. 1.07. What is the ratio of the Value added (constant 2005 US$) in Lao PDR in 1994 to that in 1995?
Offer a very short reply. 0.97. What is the ratio of the Value added (constant 2005 US$) in St. Kitts and Nevis in 1994 to that in 1995?
Keep it short and to the point. 1.21. What is the ratio of the Value added (constant 2005 US$) of Vanuatu in 1994 to that in 1995?
Give a very brief answer. 0.96. What is the ratio of the Value added (constant 2005 US$) in Japan in 1994 to that in 1996?
Offer a very short reply. 1. What is the ratio of the Value added (constant 2005 US$) of Lao PDR in 1994 to that in 1996?
Provide a succinct answer. 0.94. What is the ratio of the Value added (constant 2005 US$) in St. Kitts and Nevis in 1994 to that in 1996?
Offer a very short reply. 1.09. What is the ratio of the Value added (constant 2005 US$) in Vanuatu in 1994 to that in 1996?
Ensure brevity in your answer.  0.92. What is the ratio of the Value added (constant 2005 US$) of Japan in 1994 to that in 1997?
Your answer should be compact. 1.01. What is the ratio of the Value added (constant 2005 US$) of Lao PDR in 1994 to that in 1997?
Ensure brevity in your answer.  0.88. What is the ratio of the Value added (constant 2005 US$) of St. Kitts and Nevis in 1994 to that in 1997?
Offer a terse response. 1.06. What is the ratio of the Value added (constant 2005 US$) in Vanuatu in 1994 to that in 1997?
Your answer should be compact. 0.88. What is the ratio of the Value added (constant 2005 US$) in Japan in 1995 to that in 1996?
Give a very brief answer. 0.93. What is the ratio of the Value added (constant 2005 US$) of Lao PDR in 1995 to that in 1996?
Make the answer very short. 0.97. What is the ratio of the Value added (constant 2005 US$) of St. Kitts and Nevis in 1995 to that in 1996?
Your response must be concise. 0.9. What is the ratio of the Value added (constant 2005 US$) of Vanuatu in 1995 to that in 1996?
Offer a very short reply. 0.95. What is the ratio of the Value added (constant 2005 US$) in Japan in 1995 to that in 1997?
Provide a succinct answer. 0.95. What is the ratio of the Value added (constant 2005 US$) of Lao PDR in 1995 to that in 1997?
Offer a very short reply. 0.91. What is the ratio of the Value added (constant 2005 US$) in St. Kitts and Nevis in 1995 to that in 1997?
Make the answer very short. 0.88. What is the ratio of the Value added (constant 2005 US$) of Vanuatu in 1995 to that in 1997?
Your response must be concise. 0.91. What is the ratio of the Value added (constant 2005 US$) in Japan in 1996 to that in 1997?
Your response must be concise. 1.01. What is the ratio of the Value added (constant 2005 US$) of Lao PDR in 1996 to that in 1997?
Ensure brevity in your answer.  0.93. What is the ratio of the Value added (constant 2005 US$) of St. Kitts and Nevis in 1996 to that in 1997?
Give a very brief answer. 0.97. What is the ratio of the Value added (constant 2005 US$) of Vanuatu in 1996 to that in 1997?
Offer a very short reply. 0.96. What is the difference between the highest and the second highest Value added (constant 2005 US$) of Japan?
Your answer should be very brief. 1.02e+08. What is the difference between the highest and the second highest Value added (constant 2005 US$) in Lao PDR?
Offer a terse response. 4.55e+07. What is the difference between the highest and the second highest Value added (constant 2005 US$) in St. Kitts and Nevis?
Give a very brief answer. 2.58e+05. What is the difference between the highest and the second highest Value added (constant 2005 US$) of Vanuatu?
Make the answer very short. 3.21e+06. What is the difference between the highest and the lowest Value added (constant 2005 US$) of Japan?
Provide a succinct answer. 8.18e+09. What is the difference between the highest and the lowest Value added (constant 2005 US$) in Lao PDR?
Provide a succinct answer. 1.42e+08. What is the difference between the highest and the lowest Value added (constant 2005 US$) in St. Kitts and Nevis?
Your answer should be compact. 1.28e+06. What is the difference between the highest and the lowest Value added (constant 2005 US$) of Vanuatu?
Make the answer very short. 1.40e+07. 